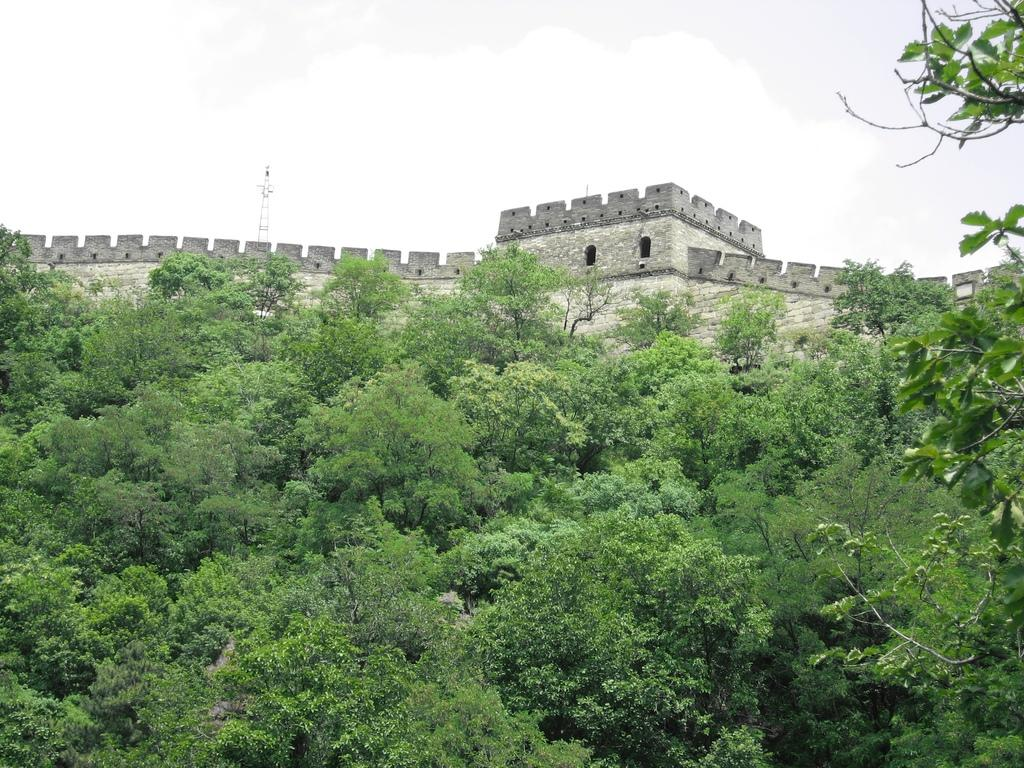What type of structure is in the image? There is a fort in the image. What is on top of the fort? There is an antenna and a small pole on top of the fort. What can be seen flying on the fort? There is a flag on the fort. What is visible in front of the fort? There are trees in front of the fort. What is visible at the top of the image? The sky is visible at the top of the image. What type of calendar is hanging on the wall inside the fort? There is no calendar visible in the image; it only shows the exterior of the fort. 